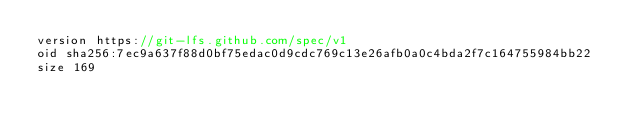<code> <loc_0><loc_0><loc_500><loc_500><_C++_>version https://git-lfs.github.com/spec/v1
oid sha256:7ec9a637f88d0bf75edac0d9cdc769c13e26afb0a0c4bda2f7c164755984bb22
size 169
</code> 